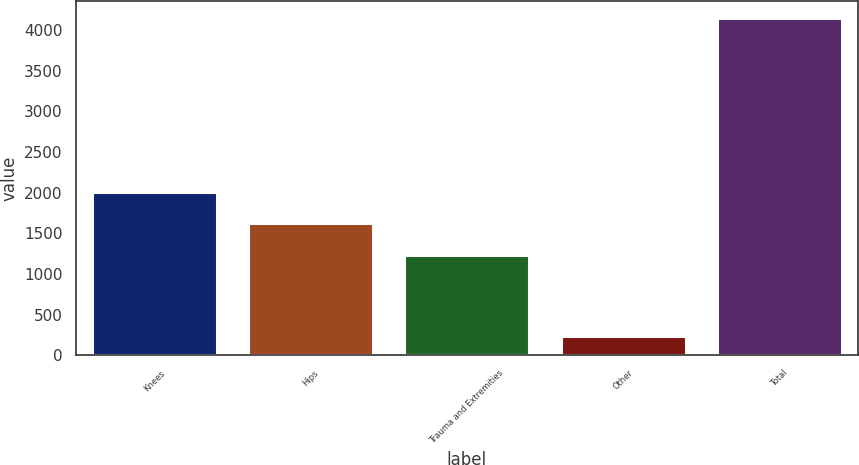Convert chart. <chart><loc_0><loc_0><loc_500><loc_500><bar_chart><fcel>Knees<fcel>Hips<fcel>Trauma and Extremities<fcel>Other<fcel>Total<nl><fcel>2013.4<fcel>1621.7<fcel>1230<fcel>236<fcel>4153<nl></chart> 